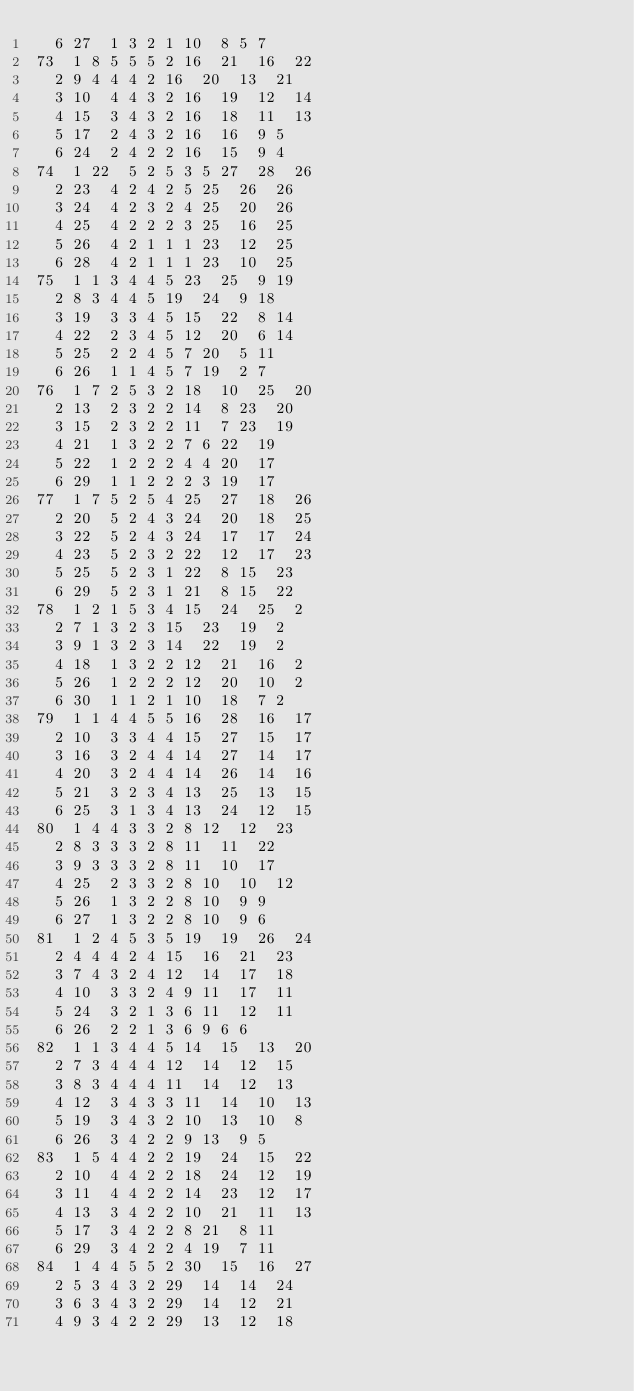<code> <loc_0><loc_0><loc_500><loc_500><_ObjectiveC_>	6	27	1	3	2	1	10	8	5	7	
73	1	8	5	5	5	2	16	21	16	22	
	2	9	4	4	4	2	16	20	13	21	
	3	10	4	4	3	2	16	19	12	14	
	4	15	3	4	3	2	16	18	11	13	
	5	17	2	4	3	2	16	16	9	5	
	6	24	2	4	2	2	16	15	9	4	
74	1	22	5	2	5	3	5	27	28	26	
	2	23	4	2	4	2	5	25	26	26	
	3	24	4	2	3	2	4	25	20	26	
	4	25	4	2	2	2	3	25	16	25	
	5	26	4	2	1	1	1	23	12	25	
	6	28	4	2	1	1	1	23	10	25	
75	1	1	3	4	4	5	23	25	9	19	
	2	8	3	4	4	5	19	24	9	18	
	3	19	3	3	4	5	15	22	8	14	
	4	22	2	3	4	5	12	20	6	14	
	5	25	2	2	4	5	7	20	5	11	
	6	26	1	1	4	5	7	19	2	7	
76	1	7	2	5	3	2	18	10	25	20	
	2	13	2	3	2	2	14	8	23	20	
	3	15	2	3	2	2	11	7	23	19	
	4	21	1	3	2	2	7	6	22	19	
	5	22	1	2	2	2	4	4	20	17	
	6	29	1	1	2	2	2	3	19	17	
77	1	7	5	2	5	4	25	27	18	26	
	2	20	5	2	4	3	24	20	18	25	
	3	22	5	2	4	3	24	17	17	24	
	4	23	5	2	3	2	22	12	17	23	
	5	25	5	2	3	1	22	8	15	23	
	6	29	5	2	3	1	21	8	15	22	
78	1	2	1	5	3	4	15	24	25	2	
	2	7	1	3	2	3	15	23	19	2	
	3	9	1	3	2	3	14	22	19	2	
	4	18	1	3	2	2	12	21	16	2	
	5	26	1	2	2	2	12	20	10	2	
	6	30	1	1	2	1	10	18	7	2	
79	1	1	4	4	5	5	16	28	16	17	
	2	10	3	3	4	4	15	27	15	17	
	3	16	3	2	4	4	14	27	14	17	
	4	20	3	2	4	4	14	26	14	16	
	5	21	3	2	3	4	13	25	13	15	
	6	25	3	1	3	4	13	24	12	15	
80	1	4	4	3	3	2	8	12	12	23	
	2	8	3	3	3	2	8	11	11	22	
	3	9	3	3	3	2	8	11	10	17	
	4	25	2	3	3	2	8	10	10	12	
	5	26	1	3	2	2	8	10	9	9	
	6	27	1	3	2	2	8	10	9	6	
81	1	2	4	5	3	5	19	19	26	24	
	2	4	4	4	2	4	15	16	21	23	
	3	7	4	3	2	4	12	14	17	18	
	4	10	3	3	2	4	9	11	17	11	
	5	24	3	2	1	3	6	11	12	11	
	6	26	2	2	1	3	6	9	6	6	
82	1	1	3	4	4	5	14	15	13	20	
	2	7	3	4	4	4	12	14	12	15	
	3	8	3	4	4	4	11	14	12	13	
	4	12	3	4	3	3	11	14	10	13	
	5	19	3	4	3	2	10	13	10	8	
	6	26	3	4	2	2	9	13	9	5	
83	1	5	4	4	2	2	19	24	15	22	
	2	10	4	4	2	2	18	24	12	19	
	3	11	4	4	2	2	14	23	12	17	
	4	13	3	4	2	2	10	21	11	13	
	5	17	3	4	2	2	8	21	8	11	
	6	29	3	4	2	2	4	19	7	11	
84	1	4	4	5	5	2	30	15	16	27	
	2	5	3	4	3	2	29	14	14	24	
	3	6	3	4	3	2	29	14	12	21	
	4	9	3	4	2	2	29	13	12	18	</code> 